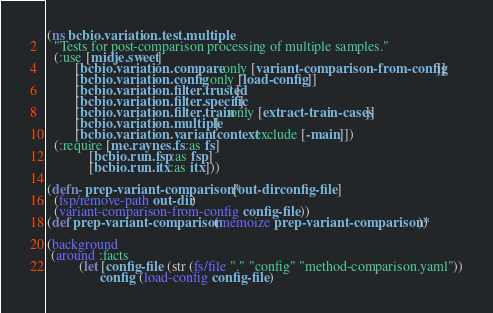Convert code to text. <code><loc_0><loc_0><loc_500><loc_500><_Clojure_>(ns bcbio.variation.test.multiple
  "Tests for post-comparison processing of multiple samples."
  (:use [midje.sweet]
        [bcbio.variation.compare :only [variant-comparison-from-config]]
        [bcbio.variation.config :only [load-config]]
        [bcbio.variation.filter.trusted]
        [bcbio.variation.filter.specific]
        [bcbio.variation.filter.train :only [extract-train-cases]]
        [bcbio.variation.multiple]
        [bcbio.variation.variantcontext :exclude [-main]])
  (:require [me.raynes.fs :as fs]
            [bcbio.run.fsp :as fsp]
            [bcbio.run.itx :as itx]))

(defn- prep-variant-comparison* [out-dir config-file]
  (fsp/remove-path out-dir)
  (variant-comparison-from-config config-file))
(def prep-variant-comparison (memoize prep-variant-comparison*))

(background
 (around :facts
         (let [config-file (str (fs/file "." "config" "method-comparison.yaml"))
               config (load-config config-file)</code> 